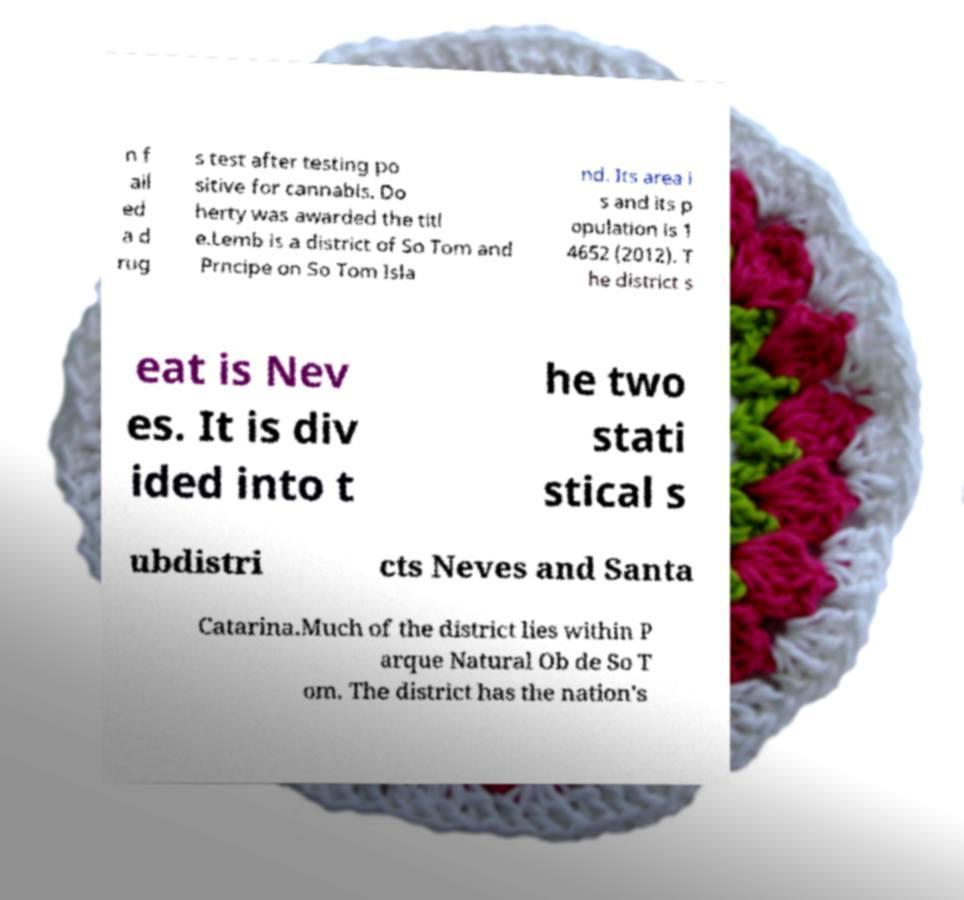I need the written content from this picture converted into text. Can you do that? n f ail ed a d rug s test after testing po sitive for cannabis. Do herty was awarded the titl e.Lemb is a district of So Tom and Prncipe on So Tom Isla nd. Its area i s and its p opulation is 1 4652 (2012). T he district s eat is Nev es. It is div ided into t he two stati stical s ubdistri cts Neves and Santa Catarina.Much of the district lies within P arque Natural Ob de So T om. The district has the nation's 